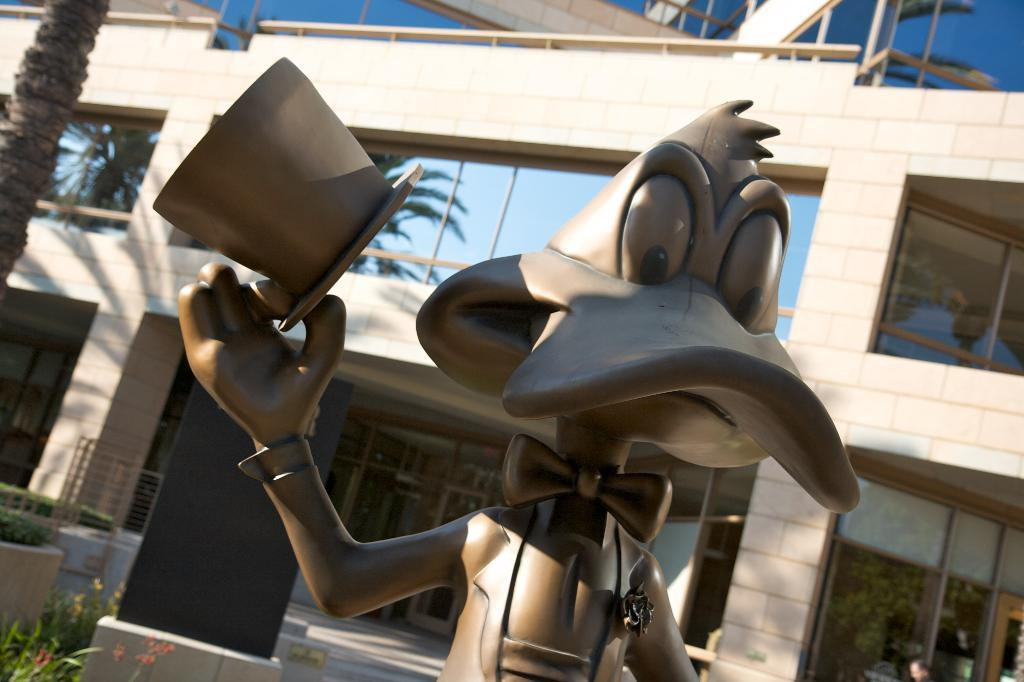What is the main subject of the image? There is a sculpture in the image. What else can be seen in the image besides the sculpture? There are buildings and plants in the image. Who created the thunder in the image? There is no thunder present in the image, and therefore no creator for it. 